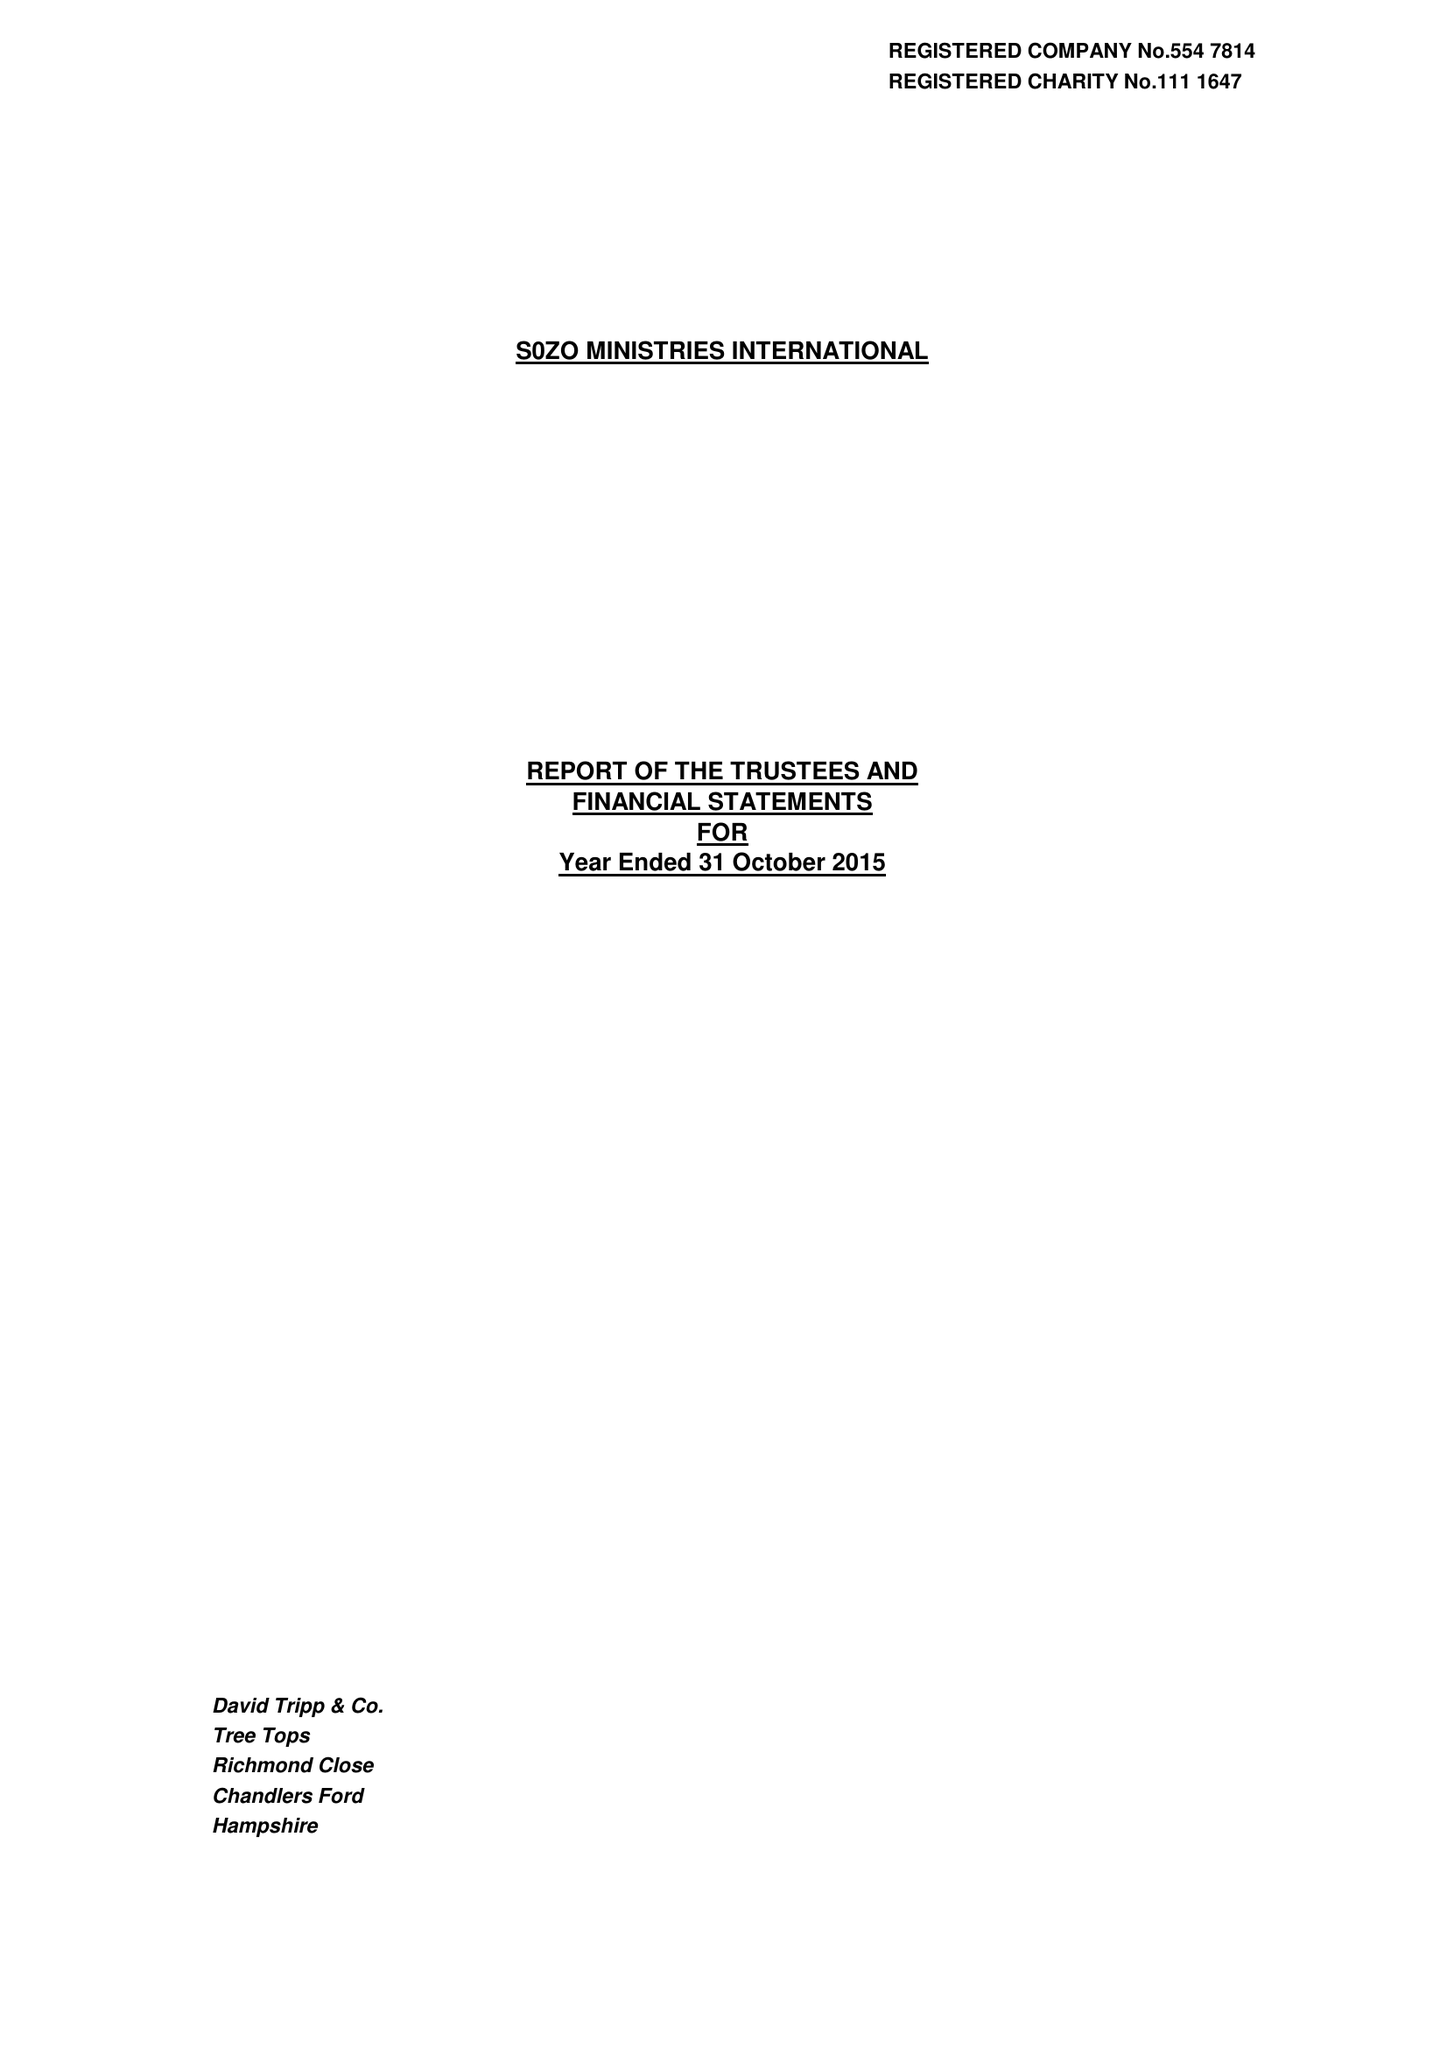What is the value for the address__post_town?
Answer the question using a single word or phrase. ROMSEY 